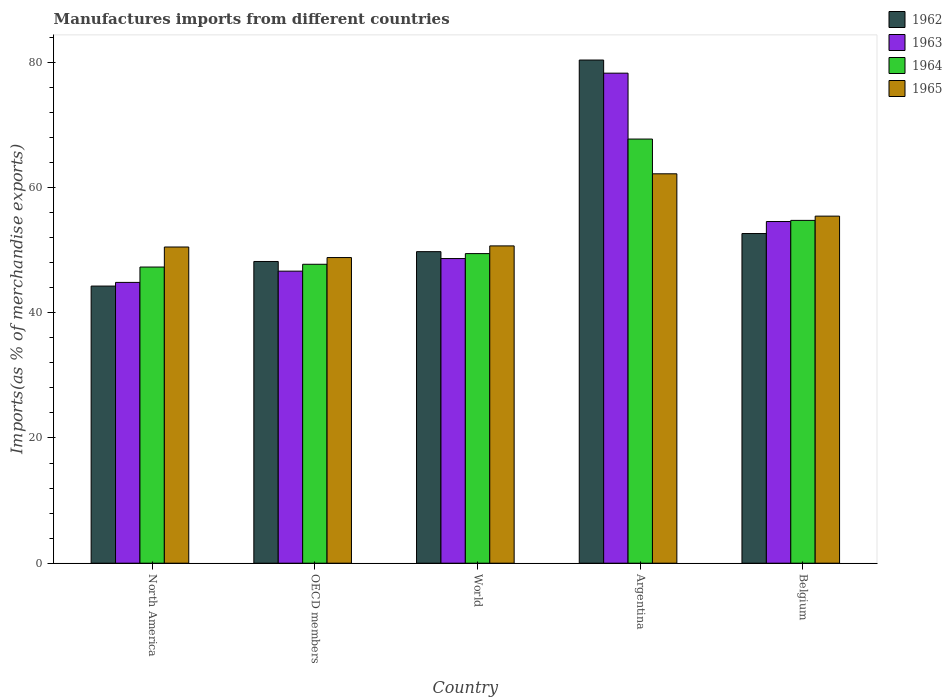How many different coloured bars are there?
Offer a terse response. 4. How many groups of bars are there?
Offer a terse response. 5. Are the number of bars per tick equal to the number of legend labels?
Make the answer very short. Yes. How many bars are there on the 1st tick from the left?
Make the answer very short. 4. How many bars are there on the 4th tick from the right?
Keep it short and to the point. 4. What is the label of the 1st group of bars from the left?
Provide a succinct answer. North America. What is the percentage of imports to different countries in 1964 in Belgium?
Offer a terse response. 54.75. Across all countries, what is the maximum percentage of imports to different countries in 1963?
Keep it short and to the point. 78.27. Across all countries, what is the minimum percentage of imports to different countries in 1964?
Offer a very short reply. 47.3. What is the total percentage of imports to different countries in 1963 in the graph?
Keep it short and to the point. 273. What is the difference between the percentage of imports to different countries in 1963 in Argentina and that in OECD members?
Offer a very short reply. 31.62. What is the difference between the percentage of imports to different countries in 1965 in World and the percentage of imports to different countries in 1963 in OECD members?
Keep it short and to the point. 4.03. What is the average percentage of imports to different countries in 1965 per country?
Your answer should be compact. 53.53. What is the difference between the percentage of imports to different countries of/in 1962 and percentage of imports to different countries of/in 1963 in Belgium?
Offer a very short reply. -1.92. What is the ratio of the percentage of imports to different countries in 1965 in Argentina to that in Belgium?
Ensure brevity in your answer.  1.12. What is the difference between the highest and the second highest percentage of imports to different countries in 1963?
Your answer should be compact. 5.91. What is the difference between the highest and the lowest percentage of imports to different countries in 1964?
Keep it short and to the point. 20.44. What does the 4th bar from the left in Belgium represents?
Your answer should be compact. 1965. What does the 4th bar from the right in OECD members represents?
Keep it short and to the point. 1962. Is it the case that in every country, the sum of the percentage of imports to different countries in 1964 and percentage of imports to different countries in 1962 is greater than the percentage of imports to different countries in 1965?
Your answer should be compact. Yes. How many bars are there?
Your response must be concise. 20. Are all the bars in the graph horizontal?
Ensure brevity in your answer.  No. Does the graph contain any zero values?
Offer a terse response. No. What is the title of the graph?
Give a very brief answer. Manufactures imports from different countries. What is the label or title of the Y-axis?
Offer a terse response. Imports(as % of merchandise exports). What is the Imports(as % of merchandise exports) of 1962 in North America?
Make the answer very short. 44.26. What is the Imports(as % of merchandise exports) in 1963 in North America?
Make the answer very short. 44.85. What is the Imports(as % of merchandise exports) in 1964 in North America?
Provide a succinct answer. 47.3. What is the Imports(as % of merchandise exports) of 1965 in North America?
Offer a terse response. 50.5. What is the Imports(as % of merchandise exports) of 1962 in OECD members?
Ensure brevity in your answer.  48.19. What is the Imports(as % of merchandise exports) in 1963 in OECD members?
Your answer should be compact. 46.65. What is the Imports(as % of merchandise exports) of 1964 in OECD members?
Keep it short and to the point. 47.75. What is the Imports(as % of merchandise exports) of 1965 in OECD members?
Your answer should be compact. 48.82. What is the Imports(as % of merchandise exports) in 1962 in World?
Offer a very short reply. 49.76. What is the Imports(as % of merchandise exports) of 1963 in World?
Your answer should be very brief. 48.66. What is the Imports(as % of merchandise exports) in 1964 in World?
Your answer should be compact. 49.45. What is the Imports(as % of merchandise exports) in 1965 in World?
Keep it short and to the point. 50.68. What is the Imports(as % of merchandise exports) of 1962 in Argentina?
Your response must be concise. 80.37. What is the Imports(as % of merchandise exports) in 1963 in Argentina?
Offer a very short reply. 78.27. What is the Imports(as % of merchandise exports) in 1964 in Argentina?
Provide a succinct answer. 67.75. What is the Imports(as % of merchandise exports) of 1965 in Argentina?
Your response must be concise. 62.19. What is the Imports(as % of merchandise exports) in 1962 in Belgium?
Keep it short and to the point. 52.65. What is the Imports(as % of merchandise exports) in 1963 in Belgium?
Provide a succinct answer. 54.57. What is the Imports(as % of merchandise exports) of 1964 in Belgium?
Give a very brief answer. 54.75. What is the Imports(as % of merchandise exports) in 1965 in Belgium?
Ensure brevity in your answer.  55.44. Across all countries, what is the maximum Imports(as % of merchandise exports) in 1962?
Offer a terse response. 80.37. Across all countries, what is the maximum Imports(as % of merchandise exports) in 1963?
Your answer should be compact. 78.27. Across all countries, what is the maximum Imports(as % of merchandise exports) in 1964?
Your response must be concise. 67.75. Across all countries, what is the maximum Imports(as % of merchandise exports) in 1965?
Offer a terse response. 62.19. Across all countries, what is the minimum Imports(as % of merchandise exports) of 1962?
Offer a very short reply. 44.26. Across all countries, what is the minimum Imports(as % of merchandise exports) in 1963?
Your answer should be compact. 44.85. Across all countries, what is the minimum Imports(as % of merchandise exports) of 1964?
Your answer should be very brief. 47.3. Across all countries, what is the minimum Imports(as % of merchandise exports) of 1965?
Provide a succinct answer. 48.82. What is the total Imports(as % of merchandise exports) in 1962 in the graph?
Provide a short and direct response. 275.24. What is the total Imports(as % of merchandise exports) in 1963 in the graph?
Your response must be concise. 273. What is the total Imports(as % of merchandise exports) in 1964 in the graph?
Keep it short and to the point. 267. What is the total Imports(as % of merchandise exports) in 1965 in the graph?
Offer a very short reply. 267.63. What is the difference between the Imports(as % of merchandise exports) in 1962 in North America and that in OECD members?
Make the answer very short. -3.93. What is the difference between the Imports(as % of merchandise exports) of 1963 in North America and that in OECD members?
Provide a succinct answer. -1.8. What is the difference between the Imports(as % of merchandise exports) of 1964 in North America and that in OECD members?
Offer a very short reply. -0.44. What is the difference between the Imports(as % of merchandise exports) in 1965 in North America and that in OECD members?
Ensure brevity in your answer.  1.68. What is the difference between the Imports(as % of merchandise exports) of 1962 in North America and that in World?
Offer a very short reply. -5.5. What is the difference between the Imports(as % of merchandise exports) of 1963 in North America and that in World?
Your answer should be compact. -3.81. What is the difference between the Imports(as % of merchandise exports) of 1964 in North America and that in World?
Offer a very short reply. -2.14. What is the difference between the Imports(as % of merchandise exports) in 1965 in North America and that in World?
Ensure brevity in your answer.  -0.18. What is the difference between the Imports(as % of merchandise exports) in 1962 in North America and that in Argentina?
Make the answer very short. -36.1. What is the difference between the Imports(as % of merchandise exports) of 1963 in North America and that in Argentina?
Provide a short and direct response. -33.42. What is the difference between the Imports(as % of merchandise exports) in 1964 in North America and that in Argentina?
Your answer should be very brief. -20.44. What is the difference between the Imports(as % of merchandise exports) of 1965 in North America and that in Argentina?
Make the answer very short. -11.69. What is the difference between the Imports(as % of merchandise exports) of 1962 in North America and that in Belgium?
Provide a short and direct response. -8.39. What is the difference between the Imports(as % of merchandise exports) in 1963 in North America and that in Belgium?
Offer a terse response. -9.72. What is the difference between the Imports(as % of merchandise exports) of 1964 in North America and that in Belgium?
Your answer should be very brief. -7.45. What is the difference between the Imports(as % of merchandise exports) in 1965 in North America and that in Belgium?
Your answer should be compact. -4.93. What is the difference between the Imports(as % of merchandise exports) of 1962 in OECD members and that in World?
Offer a terse response. -1.57. What is the difference between the Imports(as % of merchandise exports) in 1963 in OECD members and that in World?
Your answer should be compact. -2.01. What is the difference between the Imports(as % of merchandise exports) of 1964 in OECD members and that in World?
Make the answer very short. -1.7. What is the difference between the Imports(as % of merchandise exports) of 1965 in OECD members and that in World?
Your answer should be compact. -1.86. What is the difference between the Imports(as % of merchandise exports) of 1962 in OECD members and that in Argentina?
Provide a succinct answer. -32.17. What is the difference between the Imports(as % of merchandise exports) of 1963 in OECD members and that in Argentina?
Offer a terse response. -31.62. What is the difference between the Imports(as % of merchandise exports) of 1964 in OECD members and that in Argentina?
Your response must be concise. -20. What is the difference between the Imports(as % of merchandise exports) of 1965 in OECD members and that in Argentina?
Ensure brevity in your answer.  -13.38. What is the difference between the Imports(as % of merchandise exports) in 1962 in OECD members and that in Belgium?
Provide a succinct answer. -4.46. What is the difference between the Imports(as % of merchandise exports) of 1963 in OECD members and that in Belgium?
Provide a short and direct response. -7.93. What is the difference between the Imports(as % of merchandise exports) in 1964 in OECD members and that in Belgium?
Provide a short and direct response. -7.01. What is the difference between the Imports(as % of merchandise exports) of 1965 in OECD members and that in Belgium?
Offer a terse response. -6.62. What is the difference between the Imports(as % of merchandise exports) in 1962 in World and that in Argentina?
Ensure brevity in your answer.  -30.61. What is the difference between the Imports(as % of merchandise exports) of 1963 in World and that in Argentina?
Offer a very short reply. -29.61. What is the difference between the Imports(as % of merchandise exports) of 1964 in World and that in Argentina?
Ensure brevity in your answer.  -18.3. What is the difference between the Imports(as % of merchandise exports) of 1965 in World and that in Argentina?
Provide a succinct answer. -11.52. What is the difference between the Imports(as % of merchandise exports) of 1962 in World and that in Belgium?
Give a very brief answer. -2.89. What is the difference between the Imports(as % of merchandise exports) in 1963 in World and that in Belgium?
Ensure brevity in your answer.  -5.91. What is the difference between the Imports(as % of merchandise exports) in 1964 in World and that in Belgium?
Provide a succinct answer. -5.31. What is the difference between the Imports(as % of merchandise exports) in 1965 in World and that in Belgium?
Your answer should be compact. -4.76. What is the difference between the Imports(as % of merchandise exports) of 1962 in Argentina and that in Belgium?
Offer a very short reply. 27.71. What is the difference between the Imports(as % of merchandise exports) of 1963 in Argentina and that in Belgium?
Give a very brief answer. 23.7. What is the difference between the Imports(as % of merchandise exports) in 1964 in Argentina and that in Belgium?
Your answer should be very brief. 12.99. What is the difference between the Imports(as % of merchandise exports) of 1965 in Argentina and that in Belgium?
Keep it short and to the point. 6.76. What is the difference between the Imports(as % of merchandise exports) in 1962 in North America and the Imports(as % of merchandise exports) in 1963 in OECD members?
Offer a very short reply. -2.38. What is the difference between the Imports(as % of merchandise exports) in 1962 in North America and the Imports(as % of merchandise exports) in 1964 in OECD members?
Offer a very short reply. -3.48. What is the difference between the Imports(as % of merchandise exports) of 1962 in North America and the Imports(as % of merchandise exports) of 1965 in OECD members?
Offer a very short reply. -4.56. What is the difference between the Imports(as % of merchandise exports) in 1963 in North America and the Imports(as % of merchandise exports) in 1964 in OECD members?
Ensure brevity in your answer.  -2.89. What is the difference between the Imports(as % of merchandise exports) of 1963 in North America and the Imports(as % of merchandise exports) of 1965 in OECD members?
Provide a short and direct response. -3.97. What is the difference between the Imports(as % of merchandise exports) of 1964 in North America and the Imports(as % of merchandise exports) of 1965 in OECD members?
Offer a very short reply. -1.52. What is the difference between the Imports(as % of merchandise exports) in 1962 in North America and the Imports(as % of merchandise exports) in 1963 in World?
Your answer should be very brief. -4.4. What is the difference between the Imports(as % of merchandise exports) of 1962 in North America and the Imports(as % of merchandise exports) of 1964 in World?
Ensure brevity in your answer.  -5.19. What is the difference between the Imports(as % of merchandise exports) in 1962 in North America and the Imports(as % of merchandise exports) in 1965 in World?
Keep it short and to the point. -6.42. What is the difference between the Imports(as % of merchandise exports) of 1963 in North America and the Imports(as % of merchandise exports) of 1964 in World?
Ensure brevity in your answer.  -4.6. What is the difference between the Imports(as % of merchandise exports) of 1963 in North America and the Imports(as % of merchandise exports) of 1965 in World?
Keep it short and to the point. -5.83. What is the difference between the Imports(as % of merchandise exports) in 1964 in North America and the Imports(as % of merchandise exports) in 1965 in World?
Your answer should be very brief. -3.37. What is the difference between the Imports(as % of merchandise exports) of 1962 in North America and the Imports(as % of merchandise exports) of 1963 in Argentina?
Offer a very short reply. -34.01. What is the difference between the Imports(as % of merchandise exports) of 1962 in North America and the Imports(as % of merchandise exports) of 1964 in Argentina?
Give a very brief answer. -23.48. What is the difference between the Imports(as % of merchandise exports) of 1962 in North America and the Imports(as % of merchandise exports) of 1965 in Argentina?
Ensure brevity in your answer.  -17.93. What is the difference between the Imports(as % of merchandise exports) in 1963 in North America and the Imports(as % of merchandise exports) in 1964 in Argentina?
Offer a terse response. -22.89. What is the difference between the Imports(as % of merchandise exports) in 1963 in North America and the Imports(as % of merchandise exports) in 1965 in Argentina?
Provide a succinct answer. -17.34. What is the difference between the Imports(as % of merchandise exports) of 1964 in North America and the Imports(as % of merchandise exports) of 1965 in Argentina?
Offer a terse response. -14.89. What is the difference between the Imports(as % of merchandise exports) in 1962 in North America and the Imports(as % of merchandise exports) in 1963 in Belgium?
Provide a succinct answer. -10.31. What is the difference between the Imports(as % of merchandise exports) in 1962 in North America and the Imports(as % of merchandise exports) in 1964 in Belgium?
Give a very brief answer. -10.49. What is the difference between the Imports(as % of merchandise exports) in 1962 in North America and the Imports(as % of merchandise exports) in 1965 in Belgium?
Your response must be concise. -11.17. What is the difference between the Imports(as % of merchandise exports) in 1963 in North America and the Imports(as % of merchandise exports) in 1964 in Belgium?
Provide a succinct answer. -9.9. What is the difference between the Imports(as % of merchandise exports) in 1963 in North America and the Imports(as % of merchandise exports) in 1965 in Belgium?
Offer a very short reply. -10.58. What is the difference between the Imports(as % of merchandise exports) in 1964 in North America and the Imports(as % of merchandise exports) in 1965 in Belgium?
Your answer should be compact. -8.13. What is the difference between the Imports(as % of merchandise exports) in 1962 in OECD members and the Imports(as % of merchandise exports) in 1963 in World?
Make the answer very short. -0.47. What is the difference between the Imports(as % of merchandise exports) of 1962 in OECD members and the Imports(as % of merchandise exports) of 1964 in World?
Offer a very short reply. -1.26. What is the difference between the Imports(as % of merchandise exports) in 1962 in OECD members and the Imports(as % of merchandise exports) in 1965 in World?
Your answer should be compact. -2.49. What is the difference between the Imports(as % of merchandise exports) of 1963 in OECD members and the Imports(as % of merchandise exports) of 1964 in World?
Provide a succinct answer. -2.8. What is the difference between the Imports(as % of merchandise exports) in 1963 in OECD members and the Imports(as % of merchandise exports) in 1965 in World?
Give a very brief answer. -4.03. What is the difference between the Imports(as % of merchandise exports) of 1964 in OECD members and the Imports(as % of merchandise exports) of 1965 in World?
Your answer should be very brief. -2.93. What is the difference between the Imports(as % of merchandise exports) of 1962 in OECD members and the Imports(as % of merchandise exports) of 1963 in Argentina?
Provide a short and direct response. -30.08. What is the difference between the Imports(as % of merchandise exports) of 1962 in OECD members and the Imports(as % of merchandise exports) of 1964 in Argentina?
Your response must be concise. -19.55. What is the difference between the Imports(as % of merchandise exports) of 1962 in OECD members and the Imports(as % of merchandise exports) of 1965 in Argentina?
Make the answer very short. -14. What is the difference between the Imports(as % of merchandise exports) in 1963 in OECD members and the Imports(as % of merchandise exports) in 1964 in Argentina?
Give a very brief answer. -21.1. What is the difference between the Imports(as % of merchandise exports) in 1963 in OECD members and the Imports(as % of merchandise exports) in 1965 in Argentina?
Your answer should be compact. -15.55. What is the difference between the Imports(as % of merchandise exports) of 1964 in OECD members and the Imports(as % of merchandise exports) of 1965 in Argentina?
Make the answer very short. -14.45. What is the difference between the Imports(as % of merchandise exports) in 1962 in OECD members and the Imports(as % of merchandise exports) in 1963 in Belgium?
Provide a succinct answer. -6.38. What is the difference between the Imports(as % of merchandise exports) in 1962 in OECD members and the Imports(as % of merchandise exports) in 1964 in Belgium?
Offer a terse response. -6.56. What is the difference between the Imports(as % of merchandise exports) in 1962 in OECD members and the Imports(as % of merchandise exports) in 1965 in Belgium?
Keep it short and to the point. -7.24. What is the difference between the Imports(as % of merchandise exports) in 1963 in OECD members and the Imports(as % of merchandise exports) in 1964 in Belgium?
Offer a very short reply. -8.11. What is the difference between the Imports(as % of merchandise exports) of 1963 in OECD members and the Imports(as % of merchandise exports) of 1965 in Belgium?
Your answer should be very brief. -8.79. What is the difference between the Imports(as % of merchandise exports) of 1964 in OECD members and the Imports(as % of merchandise exports) of 1965 in Belgium?
Offer a terse response. -7.69. What is the difference between the Imports(as % of merchandise exports) of 1962 in World and the Imports(as % of merchandise exports) of 1963 in Argentina?
Ensure brevity in your answer.  -28.51. What is the difference between the Imports(as % of merchandise exports) in 1962 in World and the Imports(as % of merchandise exports) in 1964 in Argentina?
Your answer should be compact. -17.98. What is the difference between the Imports(as % of merchandise exports) of 1962 in World and the Imports(as % of merchandise exports) of 1965 in Argentina?
Your response must be concise. -12.43. What is the difference between the Imports(as % of merchandise exports) in 1963 in World and the Imports(as % of merchandise exports) in 1964 in Argentina?
Provide a succinct answer. -19.09. What is the difference between the Imports(as % of merchandise exports) of 1963 in World and the Imports(as % of merchandise exports) of 1965 in Argentina?
Give a very brief answer. -13.54. What is the difference between the Imports(as % of merchandise exports) of 1964 in World and the Imports(as % of merchandise exports) of 1965 in Argentina?
Offer a very short reply. -12.75. What is the difference between the Imports(as % of merchandise exports) in 1962 in World and the Imports(as % of merchandise exports) in 1963 in Belgium?
Provide a short and direct response. -4.81. What is the difference between the Imports(as % of merchandise exports) in 1962 in World and the Imports(as % of merchandise exports) in 1964 in Belgium?
Give a very brief answer. -4.99. What is the difference between the Imports(as % of merchandise exports) of 1962 in World and the Imports(as % of merchandise exports) of 1965 in Belgium?
Offer a terse response. -5.67. What is the difference between the Imports(as % of merchandise exports) of 1963 in World and the Imports(as % of merchandise exports) of 1964 in Belgium?
Provide a succinct answer. -6.09. What is the difference between the Imports(as % of merchandise exports) of 1963 in World and the Imports(as % of merchandise exports) of 1965 in Belgium?
Offer a very short reply. -6.78. What is the difference between the Imports(as % of merchandise exports) of 1964 in World and the Imports(as % of merchandise exports) of 1965 in Belgium?
Offer a very short reply. -5.99. What is the difference between the Imports(as % of merchandise exports) of 1962 in Argentina and the Imports(as % of merchandise exports) of 1963 in Belgium?
Keep it short and to the point. 25.79. What is the difference between the Imports(as % of merchandise exports) of 1962 in Argentina and the Imports(as % of merchandise exports) of 1964 in Belgium?
Offer a terse response. 25.61. What is the difference between the Imports(as % of merchandise exports) of 1962 in Argentina and the Imports(as % of merchandise exports) of 1965 in Belgium?
Make the answer very short. 24.93. What is the difference between the Imports(as % of merchandise exports) of 1963 in Argentina and the Imports(as % of merchandise exports) of 1964 in Belgium?
Offer a terse response. 23.52. What is the difference between the Imports(as % of merchandise exports) of 1963 in Argentina and the Imports(as % of merchandise exports) of 1965 in Belgium?
Keep it short and to the point. 22.83. What is the difference between the Imports(as % of merchandise exports) of 1964 in Argentina and the Imports(as % of merchandise exports) of 1965 in Belgium?
Make the answer very short. 12.31. What is the average Imports(as % of merchandise exports) of 1962 per country?
Give a very brief answer. 55.05. What is the average Imports(as % of merchandise exports) of 1963 per country?
Your answer should be compact. 54.6. What is the average Imports(as % of merchandise exports) of 1964 per country?
Provide a succinct answer. 53.4. What is the average Imports(as % of merchandise exports) of 1965 per country?
Your answer should be compact. 53.53. What is the difference between the Imports(as % of merchandise exports) in 1962 and Imports(as % of merchandise exports) in 1963 in North America?
Your answer should be compact. -0.59. What is the difference between the Imports(as % of merchandise exports) of 1962 and Imports(as % of merchandise exports) of 1964 in North America?
Make the answer very short. -3.04. What is the difference between the Imports(as % of merchandise exports) of 1962 and Imports(as % of merchandise exports) of 1965 in North America?
Your answer should be very brief. -6.24. What is the difference between the Imports(as % of merchandise exports) in 1963 and Imports(as % of merchandise exports) in 1964 in North America?
Ensure brevity in your answer.  -2.45. What is the difference between the Imports(as % of merchandise exports) of 1963 and Imports(as % of merchandise exports) of 1965 in North America?
Ensure brevity in your answer.  -5.65. What is the difference between the Imports(as % of merchandise exports) in 1964 and Imports(as % of merchandise exports) in 1965 in North America?
Ensure brevity in your answer.  -3.2. What is the difference between the Imports(as % of merchandise exports) in 1962 and Imports(as % of merchandise exports) in 1963 in OECD members?
Offer a very short reply. 1.55. What is the difference between the Imports(as % of merchandise exports) in 1962 and Imports(as % of merchandise exports) in 1964 in OECD members?
Offer a terse response. 0.45. What is the difference between the Imports(as % of merchandise exports) of 1962 and Imports(as % of merchandise exports) of 1965 in OECD members?
Keep it short and to the point. -0.63. What is the difference between the Imports(as % of merchandise exports) of 1963 and Imports(as % of merchandise exports) of 1964 in OECD members?
Ensure brevity in your answer.  -1.1. What is the difference between the Imports(as % of merchandise exports) in 1963 and Imports(as % of merchandise exports) in 1965 in OECD members?
Offer a terse response. -2.17. What is the difference between the Imports(as % of merchandise exports) in 1964 and Imports(as % of merchandise exports) in 1965 in OECD members?
Make the answer very short. -1.07. What is the difference between the Imports(as % of merchandise exports) in 1962 and Imports(as % of merchandise exports) in 1963 in World?
Your response must be concise. 1.1. What is the difference between the Imports(as % of merchandise exports) of 1962 and Imports(as % of merchandise exports) of 1964 in World?
Provide a short and direct response. 0.31. What is the difference between the Imports(as % of merchandise exports) in 1962 and Imports(as % of merchandise exports) in 1965 in World?
Provide a short and direct response. -0.92. What is the difference between the Imports(as % of merchandise exports) in 1963 and Imports(as % of merchandise exports) in 1964 in World?
Your answer should be very brief. -0.79. What is the difference between the Imports(as % of merchandise exports) of 1963 and Imports(as % of merchandise exports) of 1965 in World?
Ensure brevity in your answer.  -2.02. What is the difference between the Imports(as % of merchandise exports) in 1964 and Imports(as % of merchandise exports) in 1965 in World?
Your answer should be compact. -1.23. What is the difference between the Imports(as % of merchandise exports) of 1962 and Imports(as % of merchandise exports) of 1963 in Argentina?
Provide a succinct answer. 2.1. What is the difference between the Imports(as % of merchandise exports) of 1962 and Imports(as % of merchandise exports) of 1964 in Argentina?
Give a very brief answer. 12.62. What is the difference between the Imports(as % of merchandise exports) of 1962 and Imports(as % of merchandise exports) of 1965 in Argentina?
Ensure brevity in your answer.  18.17. What is the difference between the Imports(as % of merchandise exports) in 1963 and Imports(as % of merchandise exports) in 1964 in Argentina?
Make the answer very short. 10.52. What is the difference between the Imports(as % of merchandise exports) of 1963 and Imports(as % of merchandise exports) of 1965 in Argentina?
Give a very brief answer. 16.08. What is the difference between the Imports(as % of merchandise exports) in 1964 and Imports(as % of merchandise exports) in 1965 in Argentina?
Your answer should be very brief. 5.55. What is the difference between the Imports(as % of merchandise exports) in 1962 and Imports(as % of merchandise exports) in 1963 in Belgium?
Keep it short and to the point. -1.92. What is the difference between the Imports(as % of merchandise exports) in 1962 and Imports(as % of merchandise exports) in 1964 in Belgium?
Provide a short and direct response. -2.1. What is the difference between the Imports(as % of merchandise exports) of 1962 and Imports(as % of merchandise exports) of 1965 in Belgium?
Provide a short and direct response. -2.78. What is the difference between the Imports(as % of merchandise exports) of 1963 and Imports(as % of merchandise exports) of 1964 in Belgium?
Offer a terse response. -0.18. What is the difference between the Imports(as % of merchandise exports) in 1963 and Imports(as % of merchandise exports) in 1965 in Belgium?
Your answer should be compact. -0.86. What is the difference between the Imports(as % of merchandise exports) of 1964 and Imports(as % of merchandise exports) of 1965 in Belgium?
Ensure brevity in your answer.  -0.68. What is the ratio of the Imports(as % of merchandise exports) of 1962 in North America to that in OECD members?
Keep it short and to the point. 0.92. What is the ratio of the Imports(as % of merchandise exports) in 1963 in North America to that in OECD members?
Provide a succinct answer. 0.96. What is the ratio of the Imports(as % of merchandise exports) in 1964 in North America to that in OECD members?
Provide a succinct answer. 0.99. What is the ratio of the Imports(as % of merchandise exports) in 1965 in North America to that in OECD members?
Offer a terse response. 1.03. What is the ratio of the Imports(as % of merchandise exports) of 1962 in North America to that in World?
Provide a succinct answer. 0.89. What is the ratio of the Imports(as % of merchandise exports) in 1963 in North America to that in World?
Your response must be concise. 0.92. What is the ratio of the Imports(as % of merchandise exports) in 1964 in North America to that in World?
Your response must be concise. 0.96. What is the ratio of the Imports(as % of merchandise exports) of 1965 in North America to that in World?
Give a very brief answer. 1. What is the ratio of the Imports(as % of merchandise exports) in 1962 in North America to that in Argentina?
Provide a short and direct response. 0.55. What is the ratio of the Imports(as % of merchandise exports) in 1963 in North America to that in Argentina?
Provide a succinct answer. 0.57. What is the ratio of the Imports(as % of merchandise exports) of 1964 in North America to that in Argentina?
Keep it short and to the point. 0.7. What is the ratio of the Imports(as % of merchandise exports) of 1965 in North America to that in Argentina?
Ensure brevity in your answer.  0.81. What is the ratio of the Imports(as % of merchandise exports) of 1962 in North America to that in Belgium?
Your answer should be compact. 0.84. What is the ratio of the Imports(as % of merchandise exports) in 1963 in North America to that in Belgium?
Your answer should be compact. 0.82. What is the ratio of the Imports(as % of merchandise exports) in 1964 in North America to that in Belgium?
Your answer should be compact. 0.86. What is the ratio of the Imports(as % of merchandise exports) in 1965 in North America to that in Belgium?
Offer a very short reply. 0.91. What is the ratio of the Imports(as % of merchandise exports) of 1962 in OECD members to that in World?
Provide a succinct answer. 0.97. What is the ratio of the Imports(as % of merchandise exports) of 1963 in OECD members to that in World?
Make the answer very short. 0.96. What is the ratio of the Imports(as % of merchandise exports) in 1964 in OECD members to that in World?
Provide a short and direct response. 0.97. What is the ratio of the Imports(as % of merchandise exports) of 1965 in OECD members to that in World?
Make the answer very short. 0.96. What is the ratio of the Imports(as % of merchandise exports) of 1962 in OECD members to that in Argentina?
Keep it short and to the point. 0.6. What is the ratio of the Imports(as % of merchandise exports) in 1963 in OECD members to that in Argentina?
Provide a succinct answer. 0.6. What is the ratio of the Imports(as % of merchandise exports) in 1964 in OECD members to that in Argentina?
Give a very brief answer. 0.7. What is the ratio of the Imports(as % of merchandise exports) in 1965 in OECD members to that in Argentina?
Ensure brevity in your answer.  0.78. What is the ratio of the Imports(as % of merchandise exports) in 1962 in OECD members to that in Belgium?
Make the answer very short. 0.92. What is the ratio of the Imports(as % of merchandise exports) in 1963 in OECD members to that in Belgium?
Your response must be concise. 0.85. What is the ratio of the Imports(as % of merchandise exports) of 1964 in OECD members to that in Belgium?
Give a very brief answer. 0.87. What is the ratio of the Imports(as % of merchandise exports) of 1965 in OECD members to that in Belgium?
Provide a short and direct response. 0.88. What is the ratio of the Imports(as % of merchandise exports) in 1962 in World to that in Argentina?
Ensure brevity in your answer.  0.62. What is the ratio of the Imports(as % of merchandise exports) in 1963 in World to that in Argentina?
Give a very brief answer. 0.62. What is the ratio of the Imports(as % of merchandise exports) of 1964 in World to that in Argentina?
Offer a very short reply. 0.73. What is the ratio of the Imports(as % of merchandise exports) in 1965 in World to that in Argentina?
Provide a short and direct response. 0.81. What is the ratio of the Imports(as % of merchandise exports) of 1962 in World to that in Belgium?
Make the answer very short. 0.95. What is the ratio of the Imports(as % of merchandise exports) in 1963 in World to that in Belgium?
Your answer should be compact. 0.89. What is the ratio of the Imports(as % of merchandise exports) in 1964 in World to that in Belgium?
Your answer should be very brief. 0.9. What is the ratio of the Imports(as % of merchandise exports) in 1965 in World to that in Belgium?
Your response must be concise. 0.91. What is the ratio of the Imports(as % of merchandise exports) of 1962 in Argentina to that in Belgium?
Give a very brief answer. 1.53. What is the ratio of the Imports(as % of merchandise exports) in 1963 in Argentina to that in Belgium?
Give a very brief answer. 1.43. What is the ratio of the Imports(as % of merchandise exports) of 1964 in Argentina to that in Belgium?
Your response must be concise. 1.24. What is the ratio of the Imports(as % of merchandise exports) in 1965 in Argentina to that in Belgium?
Make the answer very short. 1.12. What is the difference between the highest and the second highest Imports(as % of merchandise exports) in 1962?
Your response must be concise. 27.71. What is the difference between the highest and the second highest Imports(as % of merchandise exports) in 1963?
Offer a very short reply. 23.7. What is the difference between the highest and the second highest Imports(as % of merchandise exports) of 1964?
Your response must be concise. 12.99. What is the difference between the highest and the second highest Imports(as % of merchandise exports) of 1965?
Your response must be concise. 6.76. What is the difference between the highest and the lowest Imports(as % of merchandise exports) of 1962?
Offer a terse response. 36.1. What is the difference between the highest and the lowest Imports(as % of merchandise exports) of 1963?
Offer a terse response. 33.42. What is the difference between the highest and the lowest Imports(as % of merchandise exports) in 1964?
Ensure brevity in your answer.  20.44. What is the difference between the highest and the lowest Imports(as % of merchandise exports) of 1965?
Give a very brief answer. 13.38. 